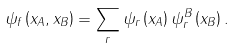Convert formula to latex. <formula><loc_0><loc_0><loc_500><loc_500>\psi _ { f } \left ( x _ { A } , x _ { B } \right ) = \sum _ { r } \psi _ { r } \left ( x _ { A } \right ) \psi _ { r } ^ { B } \left ( x _ { B } \right ) .</formula> 